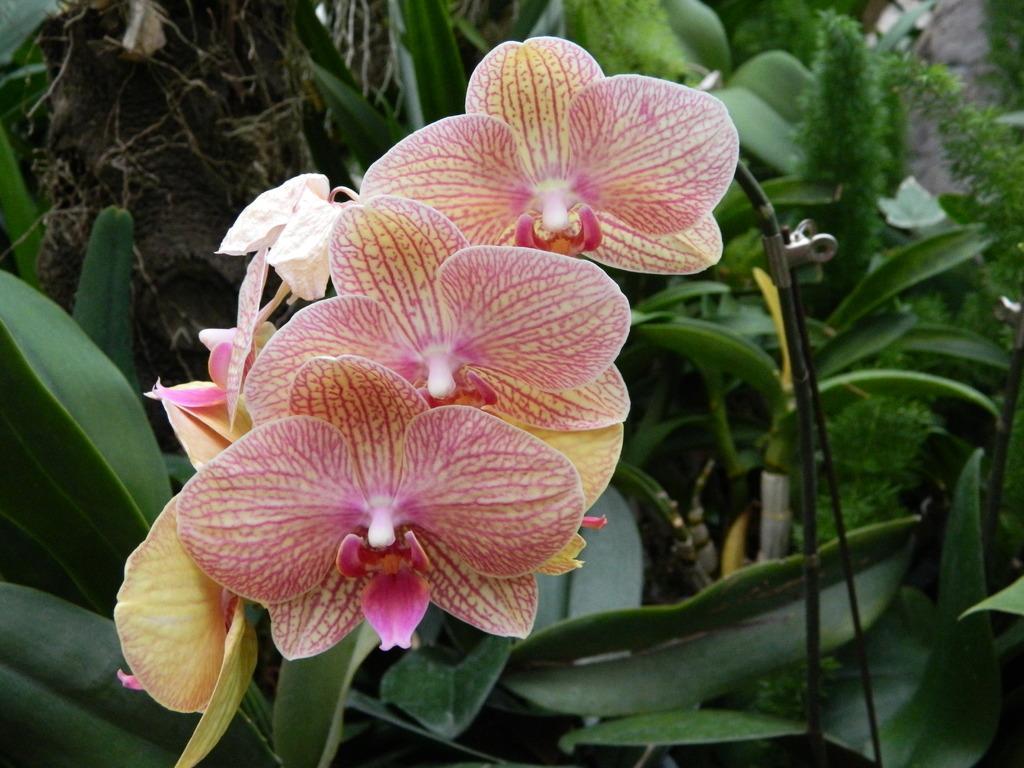How would you summarize this image in a sentence or two? In this image, I can see the plants. These are the flowers, which are pinkish in color. I can see the leaves, which are green in color. This looks like a wire. 